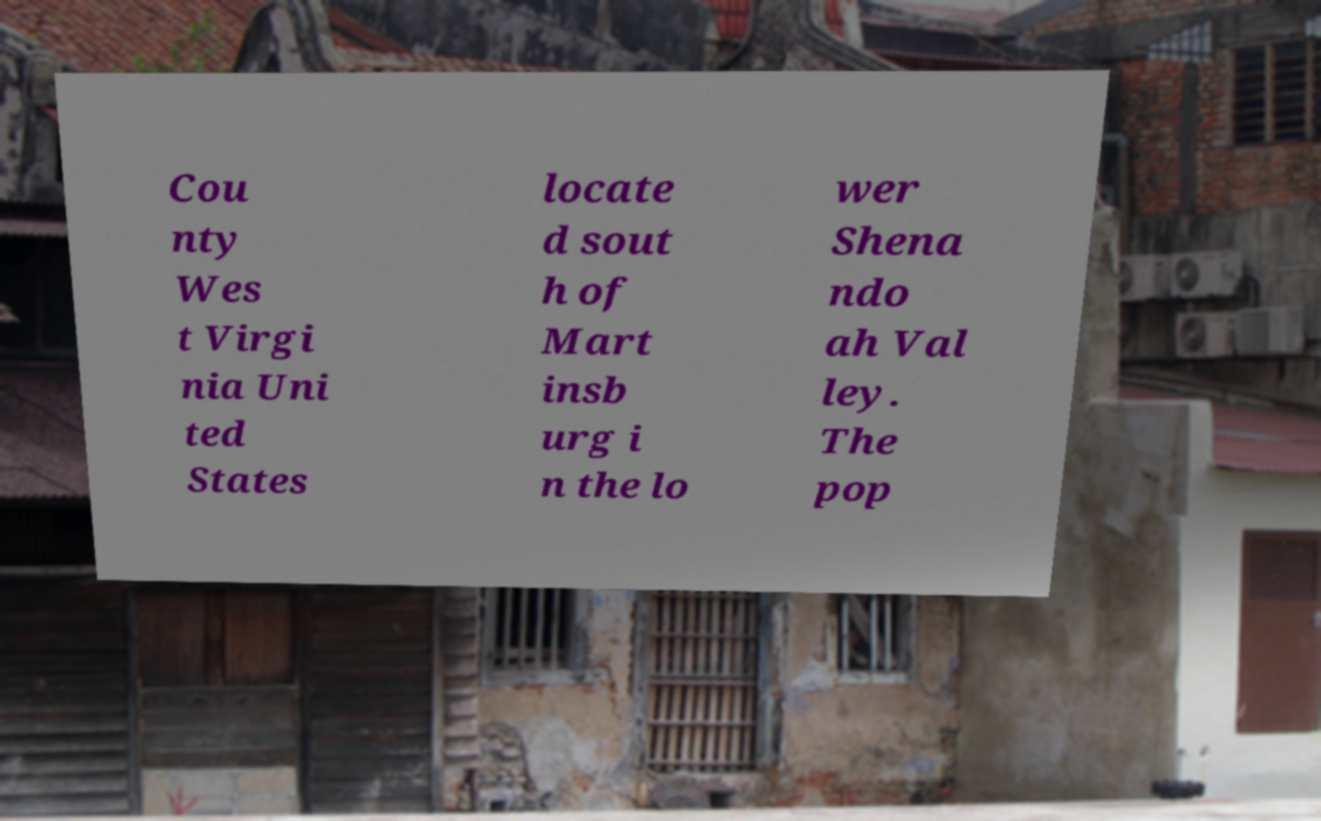I need the written content from this picture converted into text. Can you do that? Cou nty Wes t Virgi nia Uni ted States locate d sout h of Mart insb urg i n the lo wer Shena ndo ah Val ley. The pop 